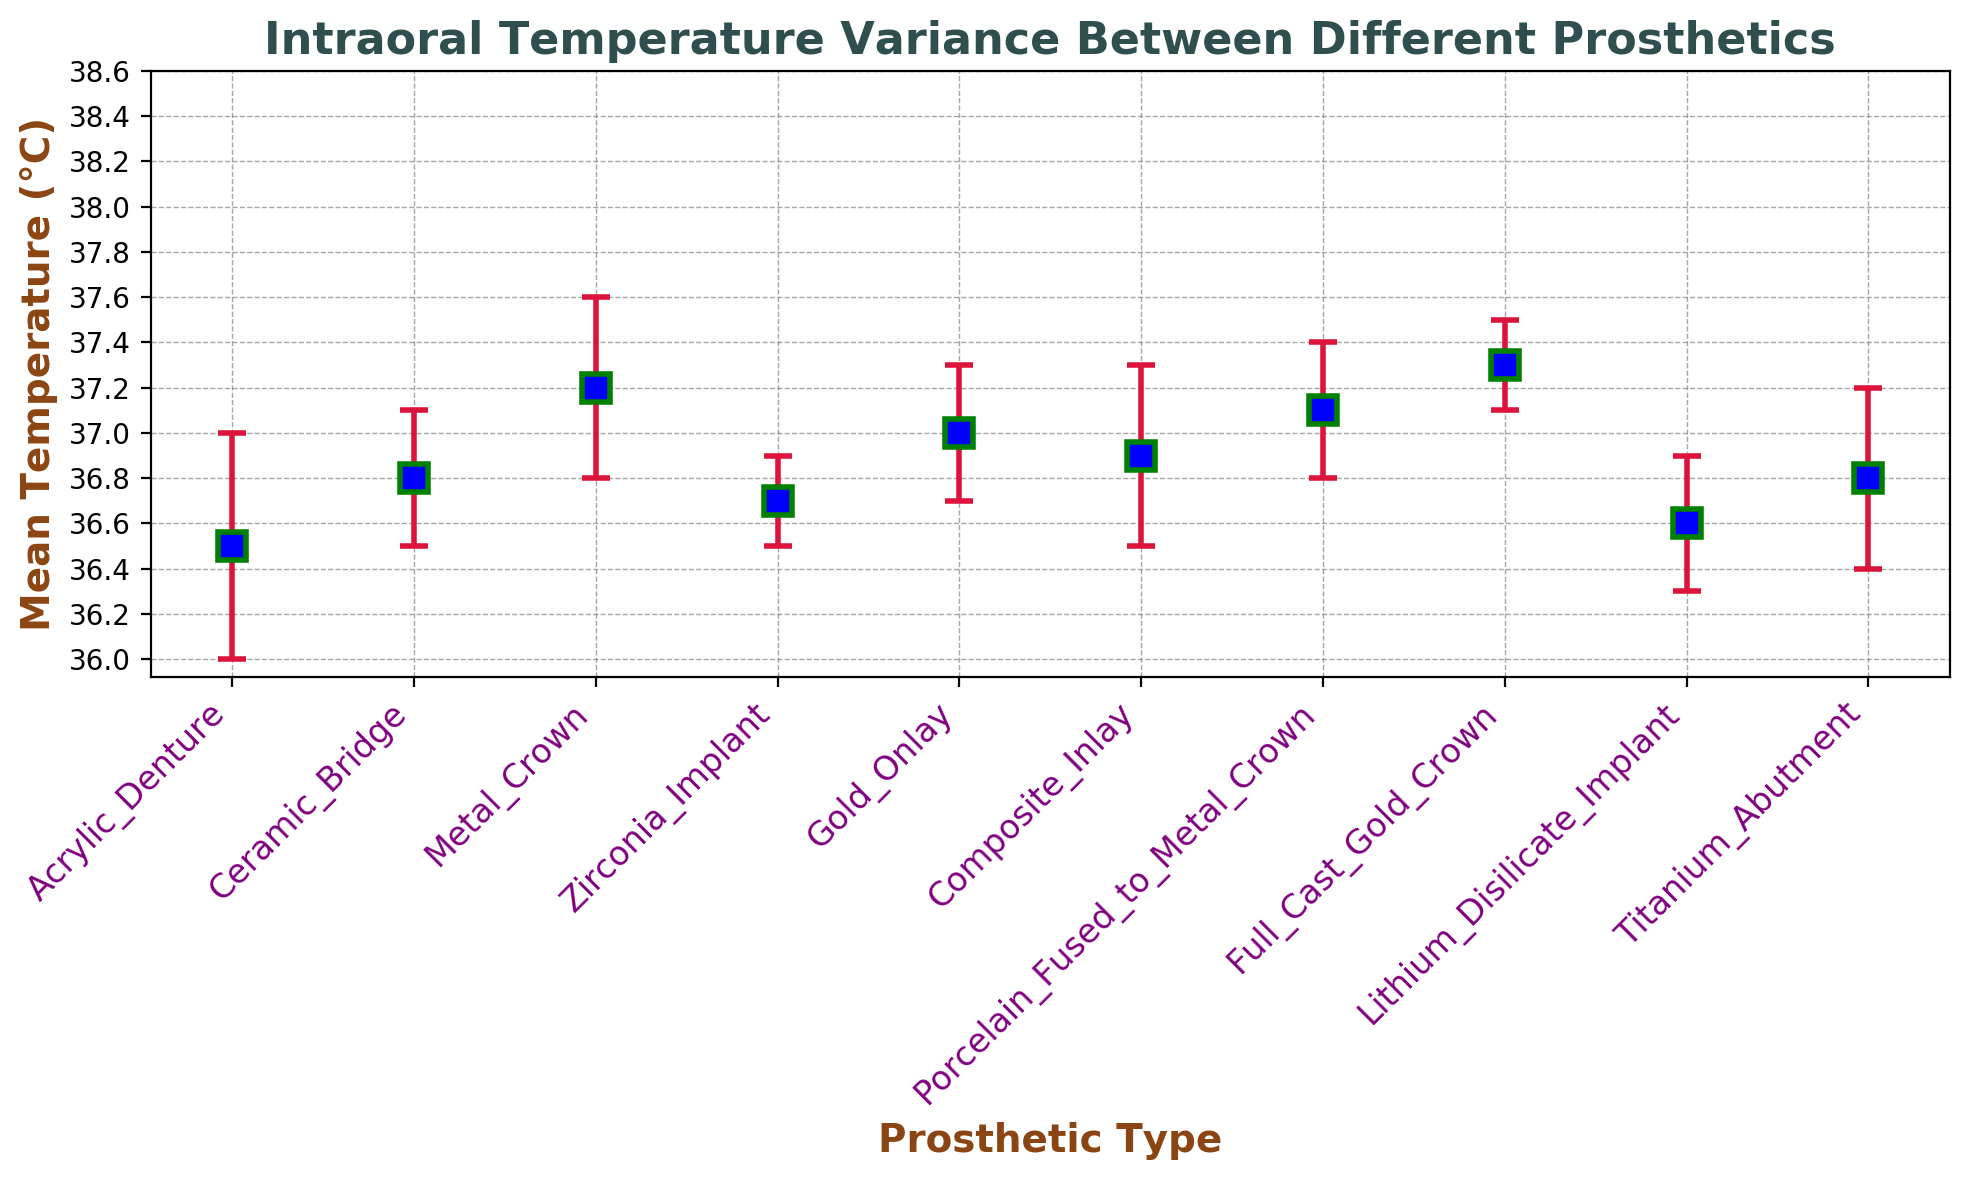Which prosthetic type has the highest mean temperature? By looking at the highest point on the y-axis, we can see that the Full Cast Gold Crown has the highest mean temperature.
Answer: Full Cast Gold Crown Which two prosthetic types have the same mean temperature? By examining the y-axis values for overlapping points, we can see that Ceramic Bridge and Titanium Abutment both have a mean temperature of 36.8°C.
Answer: Ceramic Bridge and Titanium Abutment What is the mean temperature difference between the Full Cast Gold Crown and the Acrylic Denture? The mean temperature for a Full Cast Gold Crown is 37.3°C and for an Acrylic Denture is 36.5°C. Calculate the difference: 37.3 - 36.5.
Answer: 0.8°C How does the standard error for the Metal Crown compare to the standard error for the Zirconia Implant? The standard error for the Metal Crown is 0.4 and for the Zirconia Implant is 0.2. By comparing these two values, 0.4 is greater than 0.2.
Answer: Metal Crown has a higher standard error Which prosthetic type has the lowest mean temperature? By looking at the lowest point on the y-axis, we identify that the Acrylic Denture has the lowest mean temperature.
Answer: Acrylic Denture What is the average mean temperature of all the prosthetic types? Sum all the mean temperatures (36.5 + 36.8 + 37.2 + 36.7 + 37.0 + 36.9 + 37.1 + 37.3 + 36.6 + 36.8) = 369.9°C and divide by the number of prosthetic types (10), 369.9 / 10.
Answer: 36.99°C Which prosthetic type has the largest error margin? By comparing the length of the error bars, we see that Acrylic Denture and Titanium Abutment have the largest error margin, both with a standard error of 0.4.
Answer: Acrylic Denture and Titanium Abutment Are there any prosthetic types that have a mean temperature within the range of 37.0°C to 37.2°C? Looking at the y-axis values, the prosthetic types within this range are Gold Onlay, Composite Inlay, Porcelain Fused to Metal Crown, and Metal Crown.
Answer: Gold Onlay, Composite Inlay, Porcelain Fused to Metal Crown, and Metal Crown 